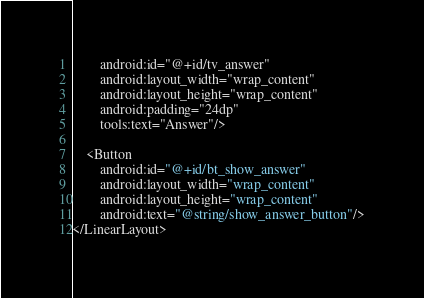Convert code to text. <code><loc_0><loc_0><loc_500><loc_500><_XML_>        android:id="@+id/tv_answer"
        android:layout_width="wrap_content"
        android:layout_height="wrap_content"
        android:padding="24dp"
        tools:text="Answer"/>

    <Button
        android:id="@+id/bt_show_answer"
        android:layout_width="wrap_content"
        android:layout_height="wrap_content"
        android:text="@string/show_answer_button"/>
</LinearLayout></code> 